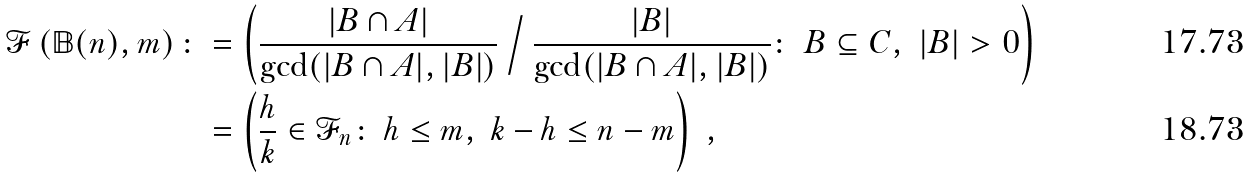Convert formula to latex. <formula><loc_0><loc_0><loc_500><loc_500>\mathcal { F } \left ( \mathbb { B } ( n ) , m \right ) \colon & = \left ( \frac { | B \cap A | } { \gcd ( | B \cap A | , | B | ) } \, \Big / \, \frac { | B | } { \gcd ( | B \cap A | , | B | ) } \colon \ B \subseteq C , \ | B | > 0 \right ) \\ & = \left ( \frac { h } { k } \in \mathcal { F } _ { n } \colon \ h \leq m , \ k - h \leq n - m \right ) \ ,</formula> 